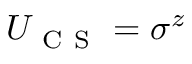Convert formula to latex. <formula><loc_0><loc_0><loc_500><loc_500>U _ { C S } = \sigma ^ { z }</formula> 